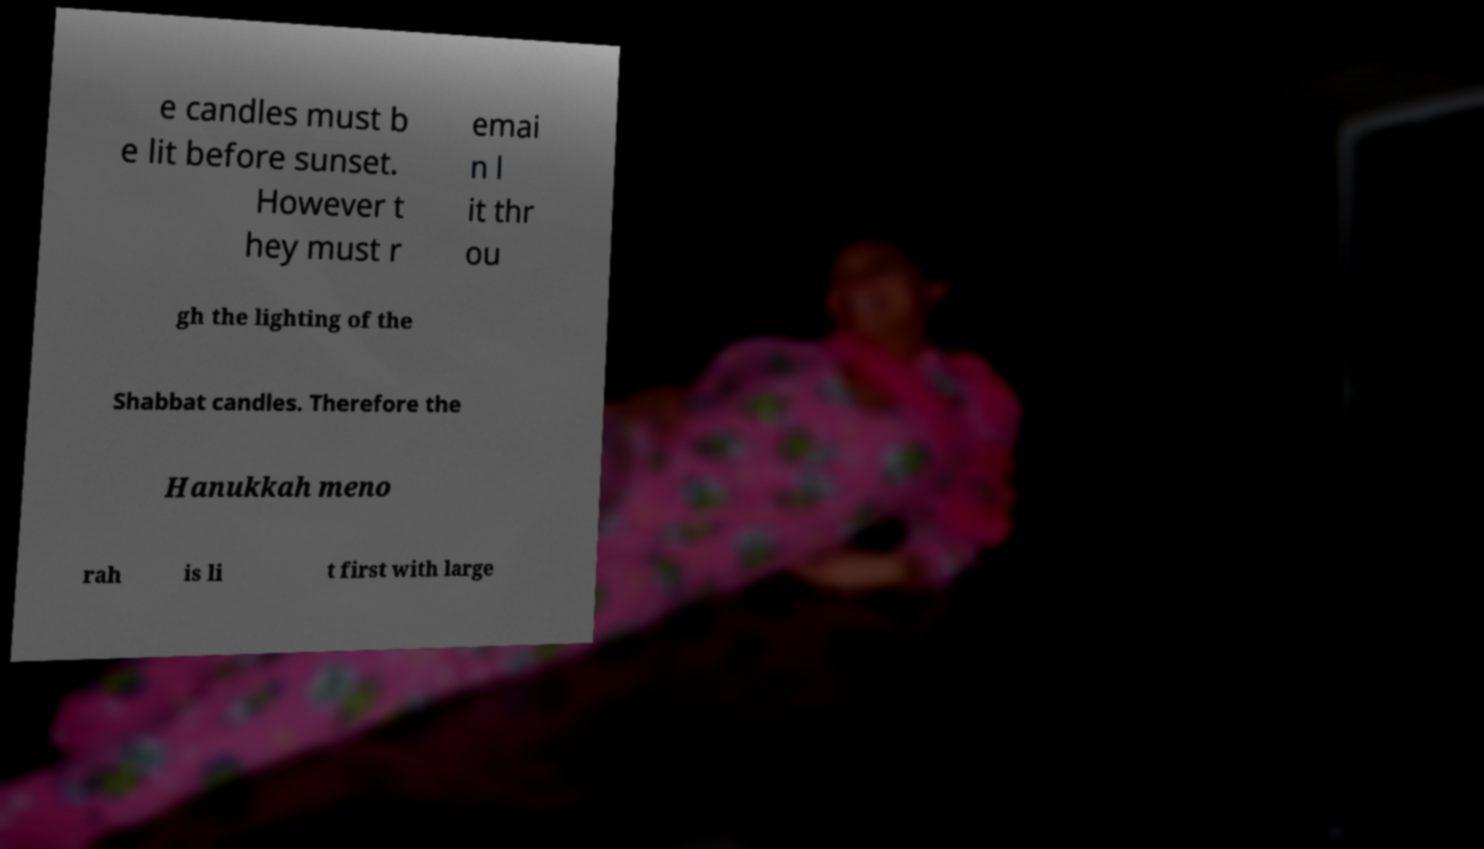Please identify and transcribe the text found in this image. e candles must b e lit before sunset. However t hey must r emai n l it thr ou gh the lighting of the Shabbat candles. Therefore the Hanukkah meno rah is li t first with large 